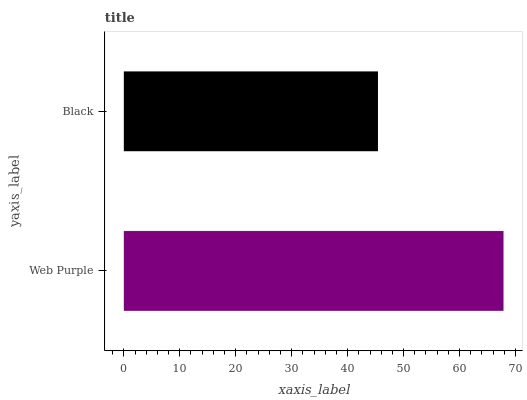Is Black the minimum?
Answer yes or no. Yes. Is Web Purple the maximum?
Answer yes or no. Yes. Is Black the maximum?
Answer yes or no. No. Is Web Purple greater than Black?
Answer yes or no. Yes. Is Black less than Web Purple?
Answer yes or no. Yes. Is Black greater than Web Purple?
Answer yes or no. No. Is Web Purple less than Black?
Answer yes or no. No. Is Web Purple the high median?
Answer yes or no. Yes. Is Black the low median?
Answer yes or no. Yes. Is Black the high median?
Answer yes or no. No. Is Web Purple the low median?
Answer yes or no. No. 